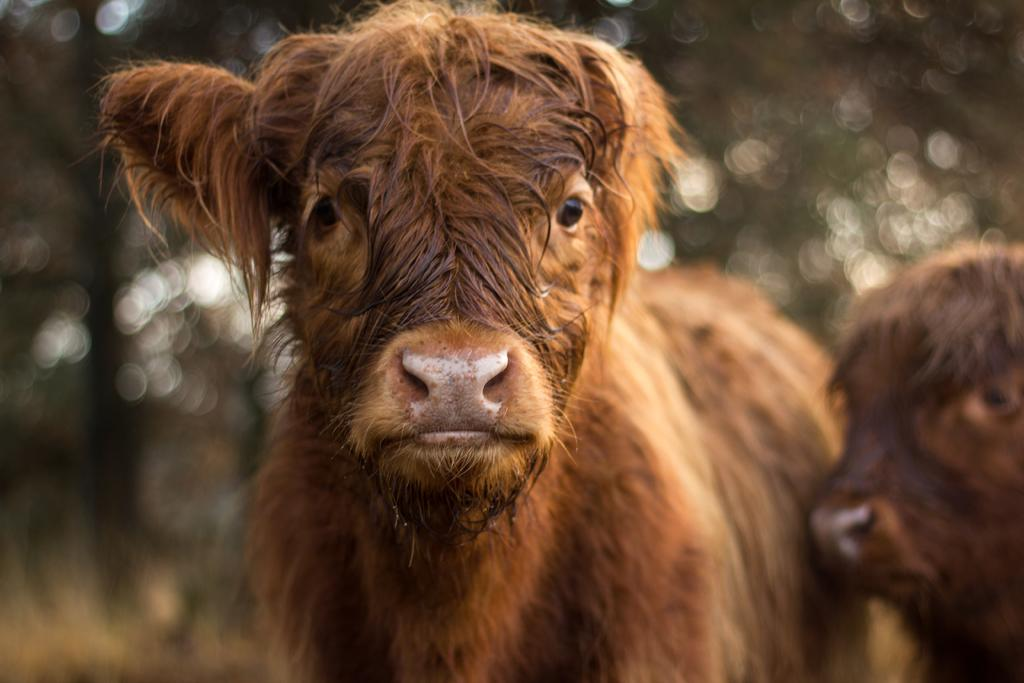What animals are present in the image? There are two cows in the picture. What color are the cows? The cows are brown in color. Can you describe the background of the image? The background of the image is not clear. What type of poison is being used to develop the cows in the image? There is no indication of any development or poison in the image; it simply features two brown cows. 